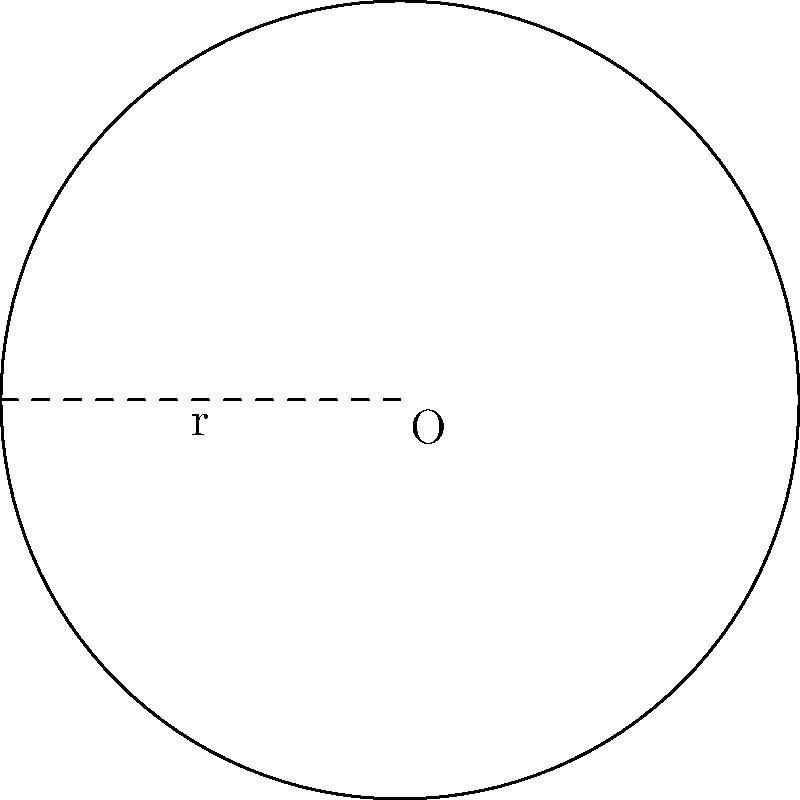You're developing a new moisture-wicking fabric and need to calculate the area of a circular sample for testing. If the radius of the sample is 5 cm, what is the area of the fabric in square centimeters? Use $\pi \approx 3.14$ for your calculations. To calculate the area of a circular fabric sample, we use the formula for the area of a circle:

$$A = \pi r^2$$

Where:
$A$ is the area of the circle
$\pi$ is approximately 3.14
$r$ is the radius of the circle

Given:
$r = 5$ cm
$\pi \approx 3.14$

Step 1: Substitute the values into the formula:
$$A = 3.14 \times 5^2$$

Step 2: Calculate the square of the radius:
$$A = 3.14 \times 25$$

Step 3: Multiply:
$$A = 78.5 \text{ cm}^2$$

Therefore, the area of the circular fabric sample is approximately 78.5 square centimeters.
Answer: $78.5 \text{ cm}^2$ 